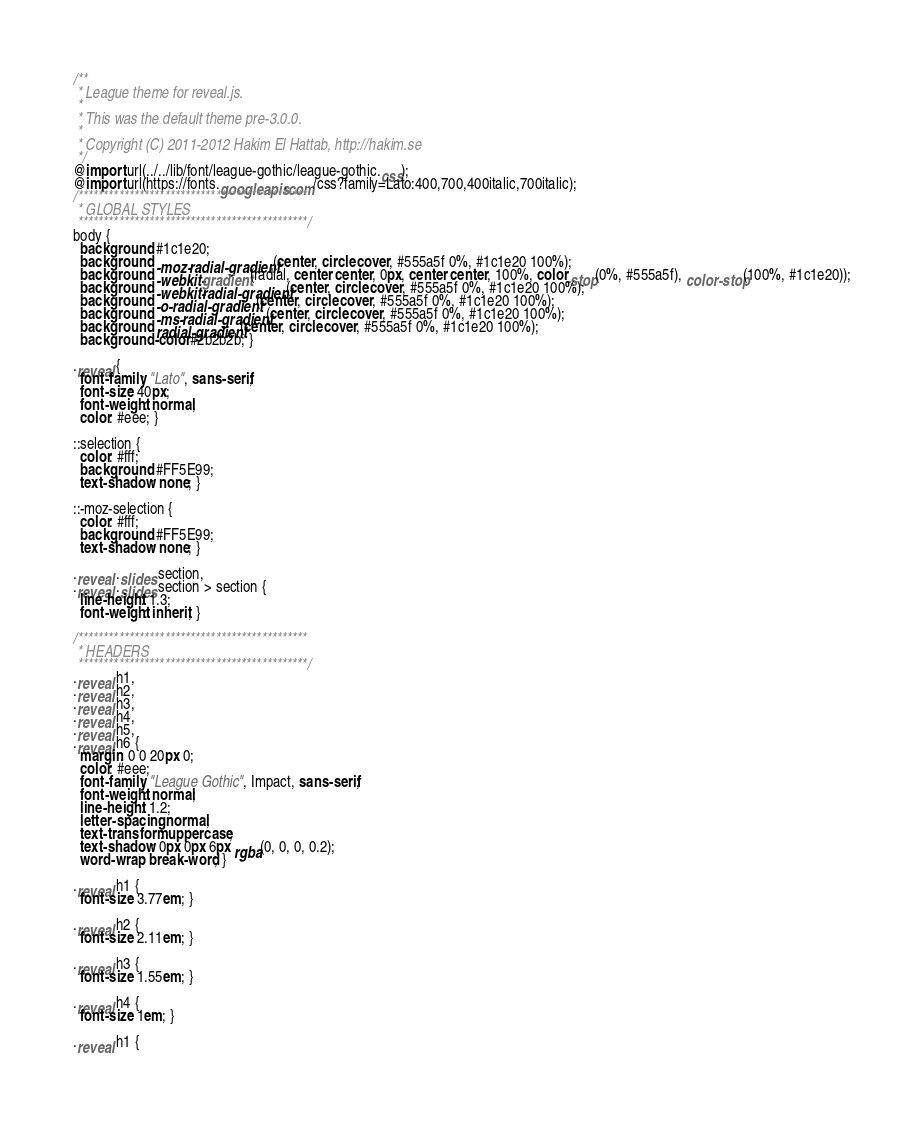<code> <loc_0><loc_0><loc_500><loc_500><_CSS_>/**
 * League theme for reveal.js.
 *
 * This was the default theme pre-3.0.0.
 *
 * Copyright (C) 2011-2012 Hakim El Hattab, http://hakim.se
 */
@import url(../../lib/font/league-gothic/league-gothic.css);
@import url(https://fonts.googleapis.com/css?family=Lato:400,700,400italic,700italic);
/*********************************************
 * GLOBAL STYLES
 *********************************************/
body {
  background: #1c1e20;
  background: -moz-radial-gradient(center, circle cover, #555a5f 0%, #1c1e20 100%);
  background: -webkit-gradient(radial, center center, 0px, center center, 100%, color-stop(0%, #555a5f), color-stop(100%, #1c1e20));
  background: -webkit-radial-gradient(center, circle cover, #555a5f 0%, #1c1e20 100%);
  background: -o-radial-gradient(center, circle cover, #555a5f 0%, #1c1e20 100%);
  background: -ms-radial-gradient(center, circle cover, #555a5f 0%, #1c1e20 100%);
  background: radial-gradient(center, circle cover, #555a5f 0%, #1c1e20 100%);
  background-color: #2b2b2b; }

.reveal {
  font-family: "Lato", sans-serif;
  font-size: 40px;
  font-weight: normal;
  color: #eee; }

::selection {
  color: #fff;
  background: #FF5E99;
  text-shadow: none; }

::-moz-selection {
  color: #fff;
  background: #FF5E99;
  text-shadow: none; }

.reveal .slides section,
.reveal .slides section > section {
  line-height: 1.3;
  font-weight: inherit; }

/*********************************************
 * HEADERS
 *********************************************/
.reveal h1,
.reveal h2,
.reveal h3,
.reveal h4,
.reveal h5,
.reveal h6 {
  margin: 0 0 20px 0;
  color: #eee;
  font-family: "League Gothic", Impact, sans-serif;
  font-weight: normal;
  line-height: 1.2;
  letter-spacing: normal;
  text-transform: uppercase;
  text-shadow: 0px 0px 6px rgba(0, 0, 0, 0.2);
  word-wrap: break-word; }

.reveal h1 {
  font-size: 3.77em; }

.reveal h2 {
  font-size: 2.11em; }

.reveal h3 {
  font-size: 1.55em; }

.reveal h4 {
  font-size: 1em; }

.reveal h1 {</code> 